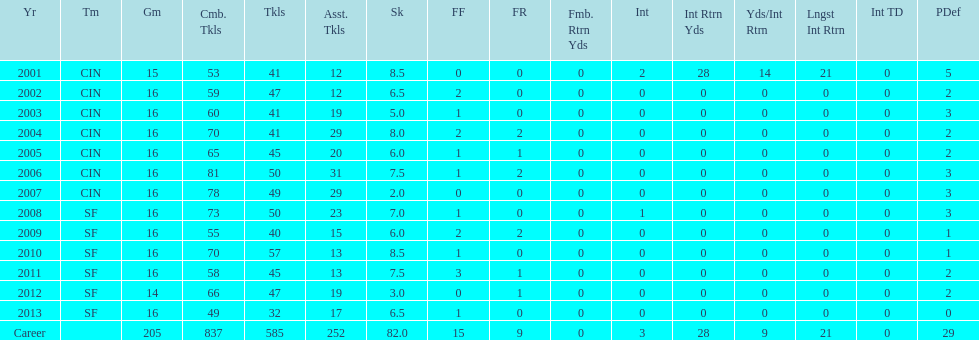What is the average number of tackles this player has had over his career? 45. 